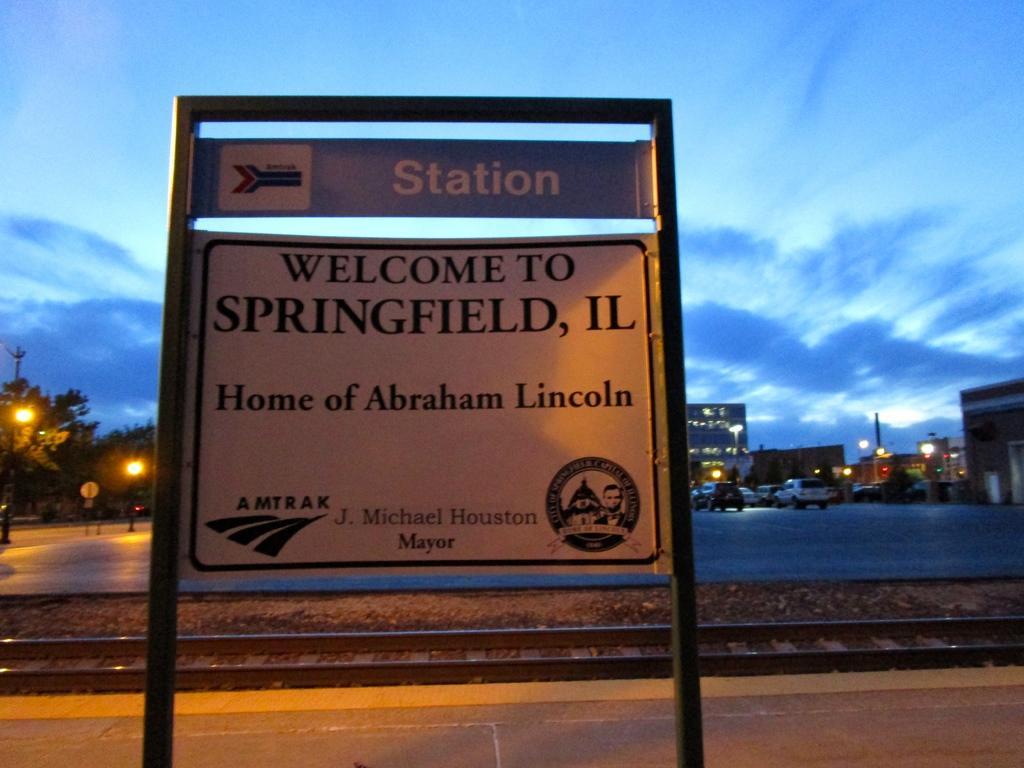In one or two sentences, can you explain what this image depicts? In this picture there is a sign board on the platform, beside that I can see the railway tracks. In the back I can see some cars were parking area. In the background I can see many buildings, trees, street lights, poles and towers. At the top I can see the sky and clouds. 